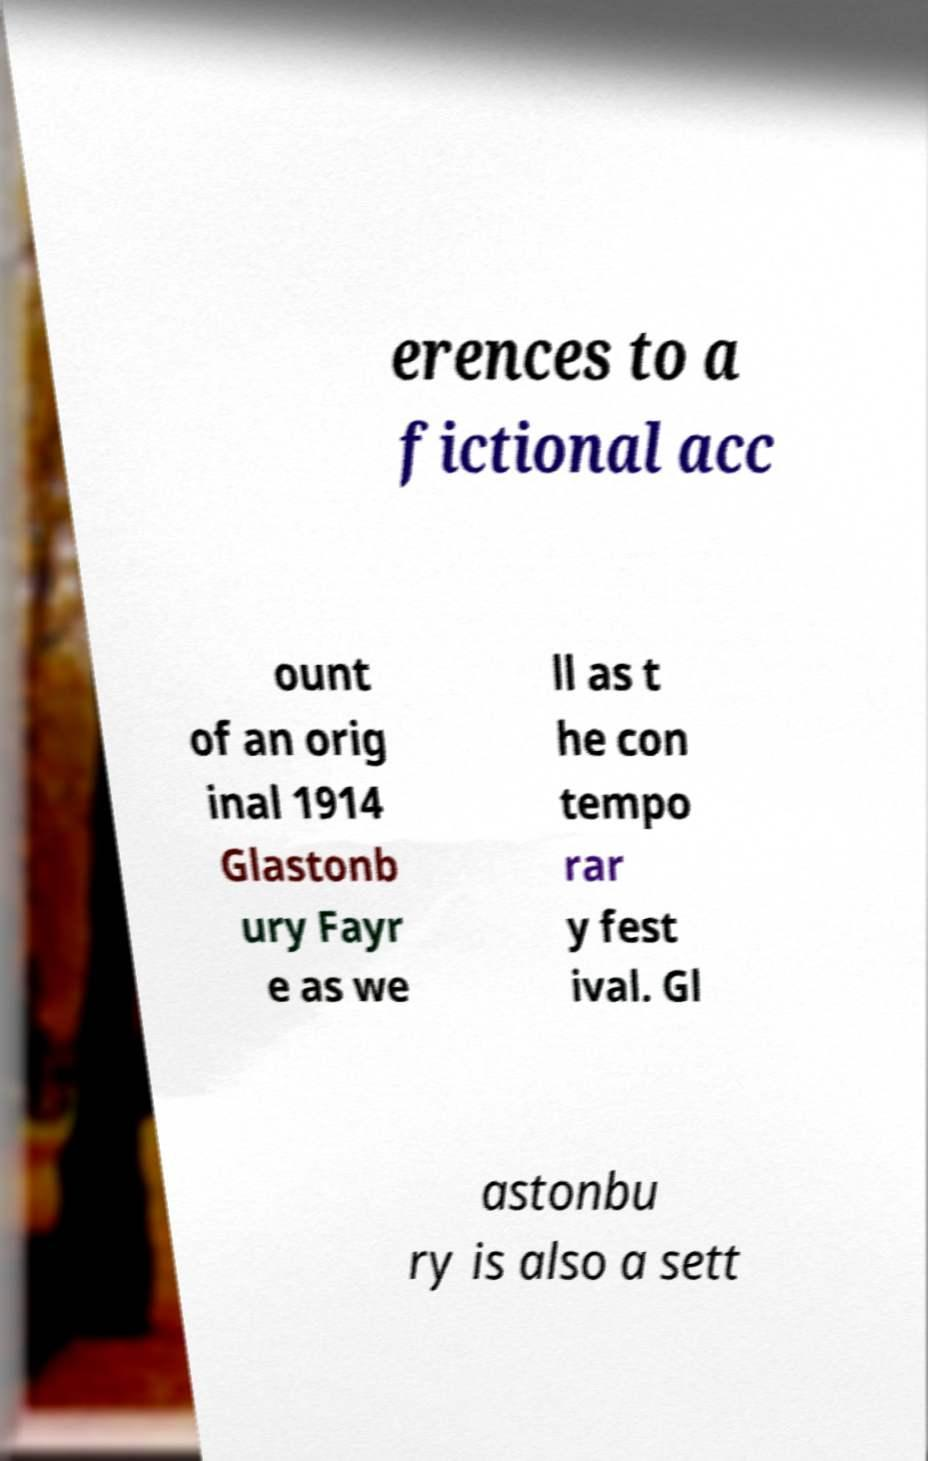Could you assist in decoding the text presented in this image and type it out clearly? erences to a fictional acc ount of an orig inal 1914 Glastonb ury Fayr e as we ll as t he con tempo rar y fest ival. Gl astonbu ry is also a sett 